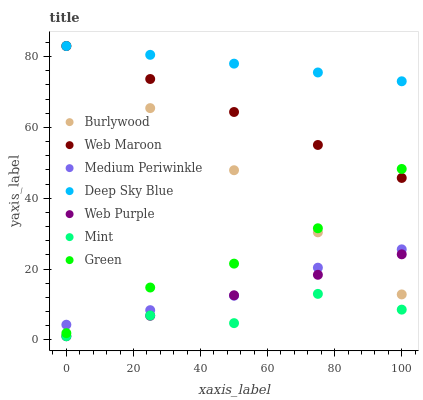Does Mint have the minimum area under the curve?
Answer yes or no. Yes. Does Deep Sky Blue have the maximum area under the curve?
Answer yes or no. Yes. Does Web Maroon have the minimum area under the curve?
Answer yes or no. No. Does Web Maroon have the maximum area under the curve?
Answer yes or no. No. Is Web Purple the smoothest?
Answer yes or no. Yes. Is Mint the roughest?
Answer yes or no. Yes. Is Web Maroon the smoothest?
Answer yes or no. No. Is Web Maroon the roughest?
Answer yes or no. No. Does Web Purple have the lowest value?
Answer yes or no. Yes. Does Web Maroon have the lowest value?
Answer yes or no. No. Does Deep Sky Blue have the highest value?
Answer yes or no. Yes. Does Medium Periwinkle have the highest value?
Answer yes or no. No. Is Mint less than Burlywood?
Answer yes or no. Yes. Is Deep Sky Blue greater than Medium Periwinkle?
Answer yes or no. Yes. Does Medium Periwinkle intersect Burlywood?
Answer yes or no. Yes. Is Medium Periwinkle less than Burlywood?
Answer yes or no. No. Is Medium Periwinkle greater than Burlywood?
Answer yes or no. No. Does Mint intersect Burlywood?
Answer yes or no. No. 